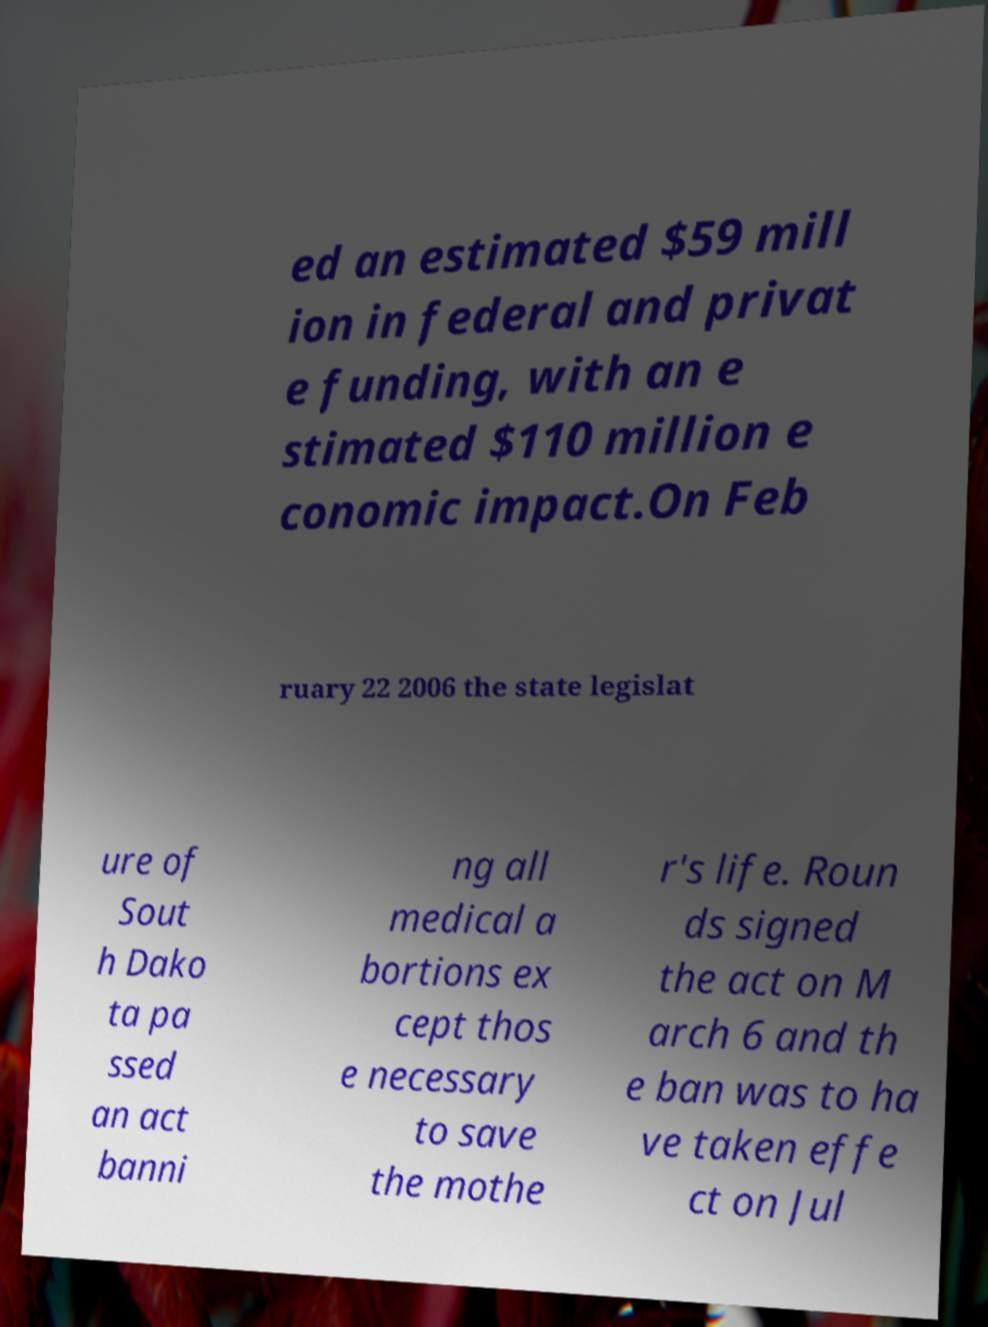For documentation purposes, I need the text within this image transcribed. Could you provide that? ed an estimated $59 mill ion in federal and privat e funding, with an e stimated $110 million e conomic impact.On Feb ruary 22 2006 the state legislat ure of Sout h Dako ta pa ssed an act banni ng all medical a bortions ex cept thos e necessary to save the mothe r's life. Roun ds signed the act on M arch 6 and th e ban was to ha ve taken effe ct on Jul 